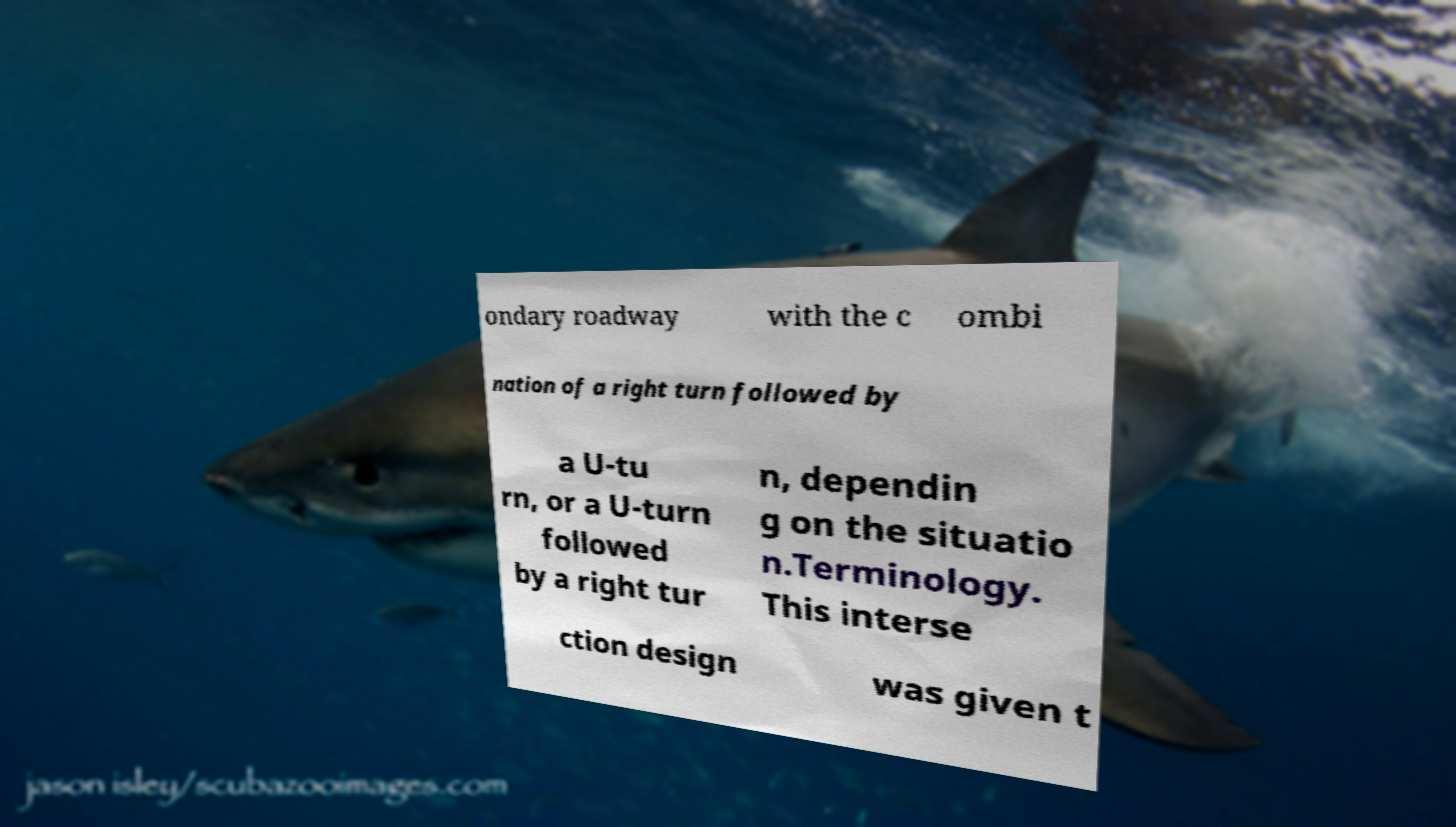For documentation purposes, I need the text within this image transcribed. Could you provide that? ondary roadway with the c ombi nation of a right turn followed by a U-tu rn, or a U-turn followed by a right tur n, dependin g on the situatio n.Terminology. This interse ction design was given t 